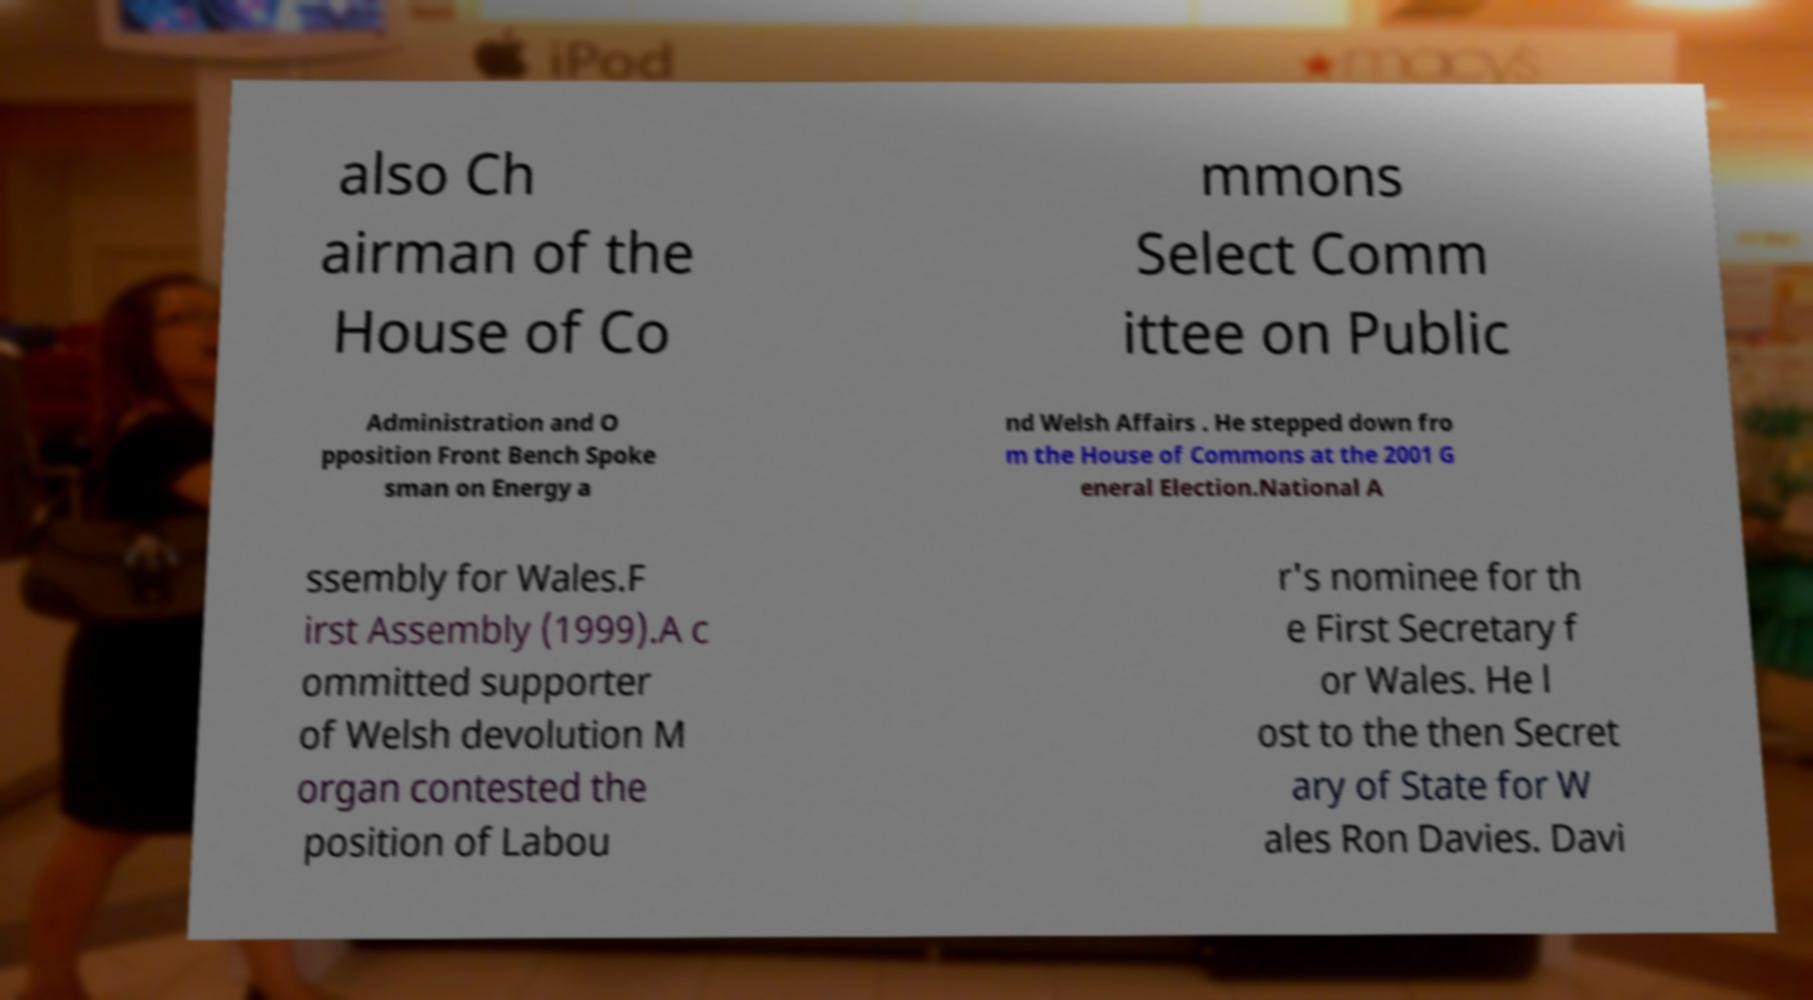For documentation purposes, I need the text within this image transcribed. Could you provide that? also Ch airman of the House of Co mmons Select Comm ittee on Public Administration and O pposition Front Bench Spoke sman on Energy a nd Welsh Affairs . He stepped down fro m the House of Commons at the 2001 G eneral Election.National A ssembly for Wales.F irst Assembly (1999).A c ommitted supporter of Welsh devolution M organ contested the position of Labou r's nominee for th e First Secretary f or Wales. He l ost to the then Secret ary of State for W ales Ron Davies. Davi 